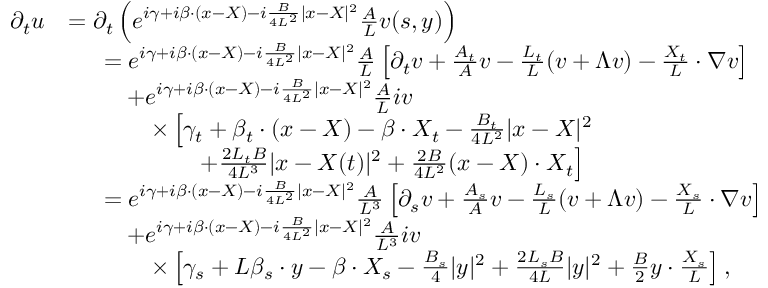<formula> <loc_0><loc_0><loc_500><loc_500>\begin{array} { r l } { \partial _ { t } u } & { = \partial _ { t } \left ( e ^ { i \gamma + i \beta \cdot ( x - X ) - i \frac { B } { 4 L ^ { 2 } } | x - X | ^ { 2 } } \frac { A } { L } v ( s , y ) \right ) } \\ & { \begin{array} { r l } & { = e ^ { i \gamma + i \beta \cdot ( x - X ) - i \frac { B } { 4 L ^ { 2 } } | x - X | ^ { 2 } } \frac { A } { L } \left [ \partial _ { t } v + \frac { A _ { t } } { A } v - \frac { L _ { t } } { L } ( v + \Lambda v ) - \frac { X _ { t } } { L } \cdot \nabla v \right ] } \\ & { \quad + e ^ { i \gamma + i \beta \cdot ( x - X ) - i \frac { B } { 4 L ^ { 2 } } | x - X | ^ { 2 } } \frac { A } { L } i v } \\ & { \quad \times \left [ \gamma _ { t } + \beta _ { t } \cdot ( x - X ) - \beta \cdot X _ { t } - \frac { B _ { t } } { 4 L ^ { 2 } } | x - X | ^ { 2 } } \\ & { \quad + \frac { 2 L _ { t } B } { 4 L ^ { 3 } } | x - X ( t ) | ^ { 2 } + \frac { 2 B } { 4 L ^ { 2 } } ( x - X ) \cdot X _ { t } \right ] } \end{array} } \\ & { \begin{array} { r l } & { = e ^ { i \gamma + i \beta \cdot ( x - X ) - i \frac { B } { 4 L ^ { 2 } } | x - X | ^ { 2 } } \frac { A } { L ^ { 3 } } \left [ \partial _ { s } v + \frac { A _ { s } } { A } v - \frac { L _ { s } } { L } ( v + \Lambda v ) - \frac { X _ { s } } { L } \cdot \nabla v \right ] } \\ & { \quad + e ^ { i \gamma + i \beta \cdot ( x - X ) - i \frac { B } { 4 L ^ { 2 } } | x - X | ^ { 2 } } \frac { A } { L ^ { 3 } } i v } \\ & { \quad \times \left [ \gamma _ { s } + L \beta _ { s } \cdot y - \beta \cdot X _ { s } - \frac { B _ { s } } { 4 } | y | ^ { 2 } + \frac { 2 L _ { s } B } { 4 L } | y | ^ { 2 } + \frac { B } { 2 } y \cdot \frac { X _ { s } } { L } \right ] , } \end{array} } \end{array}</formula> 